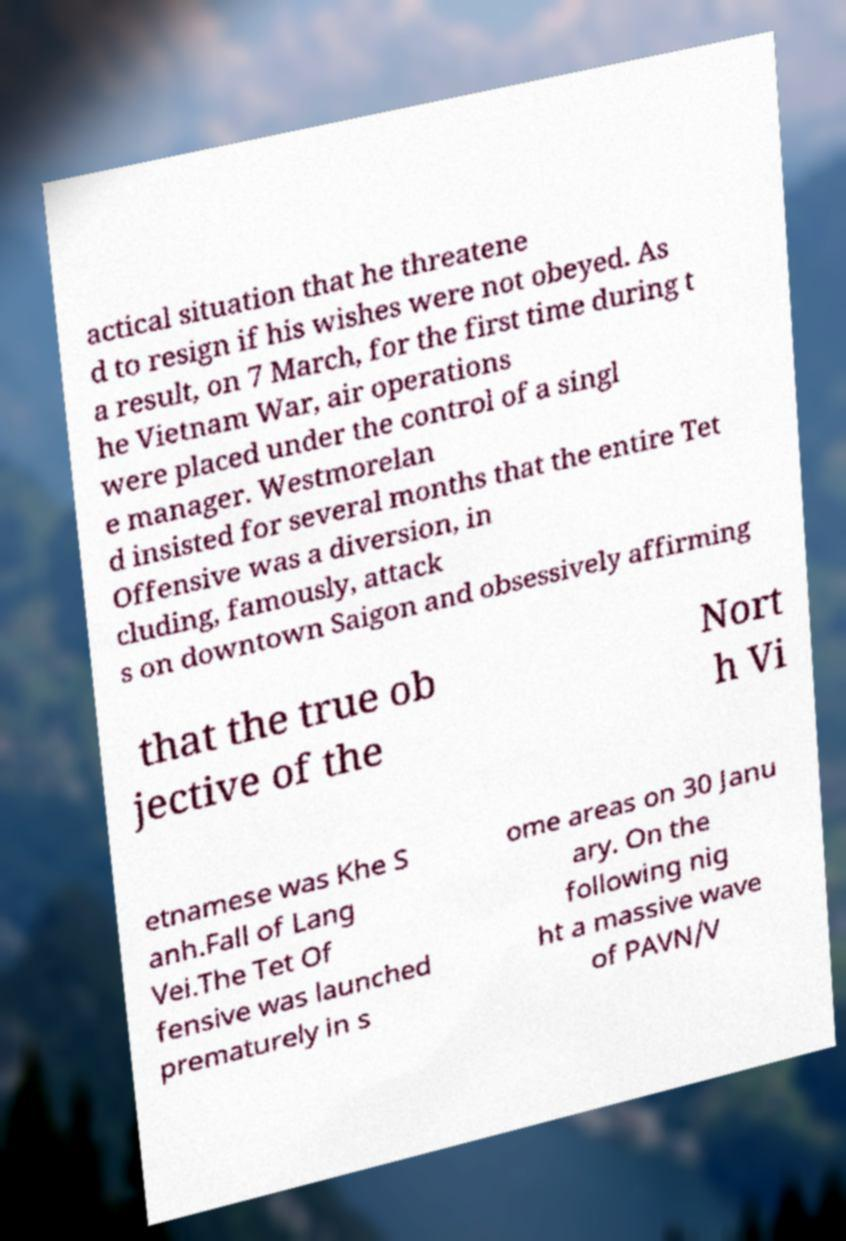What messages or text are displayed in this image? I need them in a readable, typed format. actical situation that he threatene d to resign if his wishes were not obeyed. As a result, on 7 March, for the first time during t he Vietnam War, air operations were placed under the control of a singl e manager. Westmorelan d insisted for several months that the entire Tet Offensive was a diversion, in cluding, famously, attack s on downtown Saigon and obsessively affirming that the true ob jective of the Nort h Vi etnamese was Khe S anh.Fall of Lang Vei.The Tet Of fensive was launched prematurely in s ome areas on 30 Janu ary. On the following nig ht a massive wave of PAVN/V 